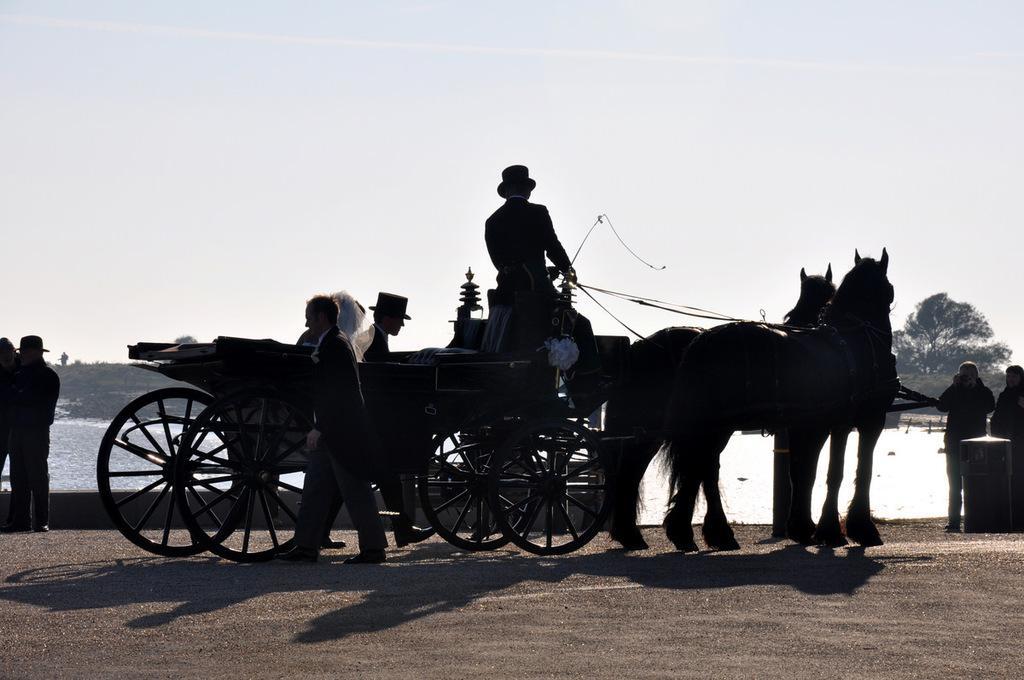In one or two sentences, can you explain what this image depicts? in the picture we can see a horse cart and many persons walking near the cart we can see the person sitting on the cart,we can see the water and we can also see the clear sky. 